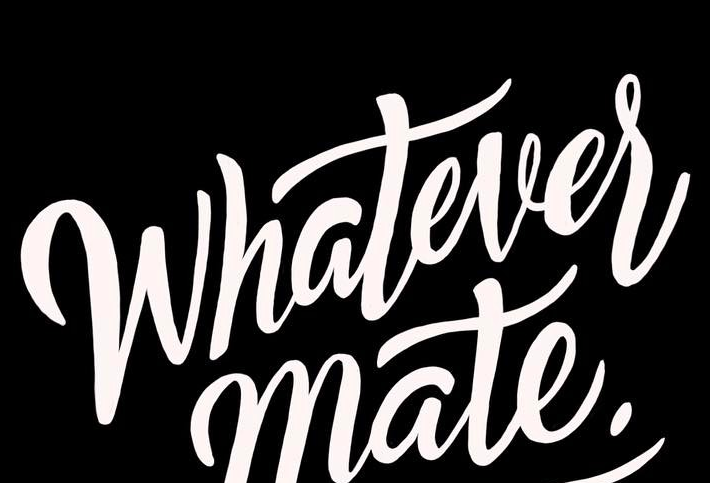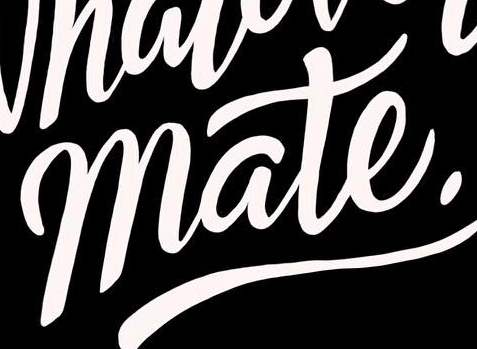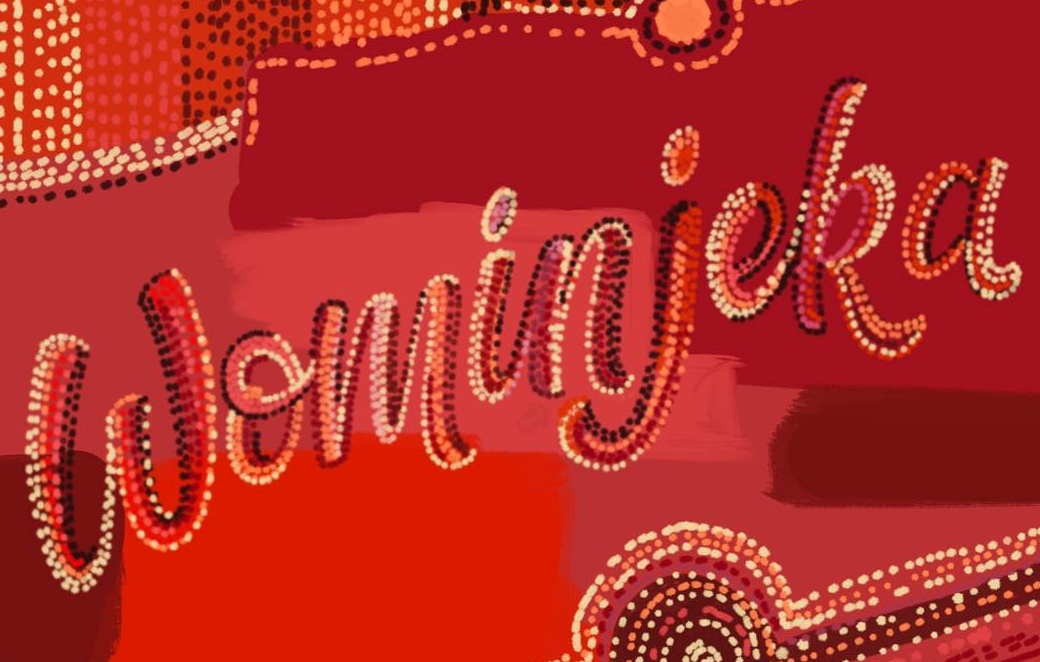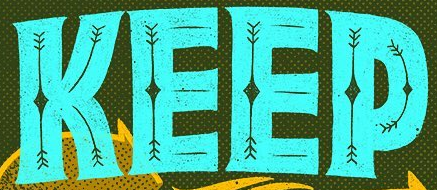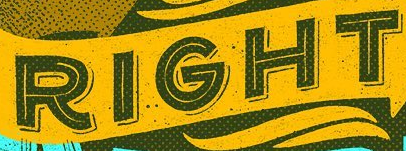What text is displayed in these images sequentially, separated by a semicolon? Whatever; mate.; Wominjeka; KEEP; RIGHT 